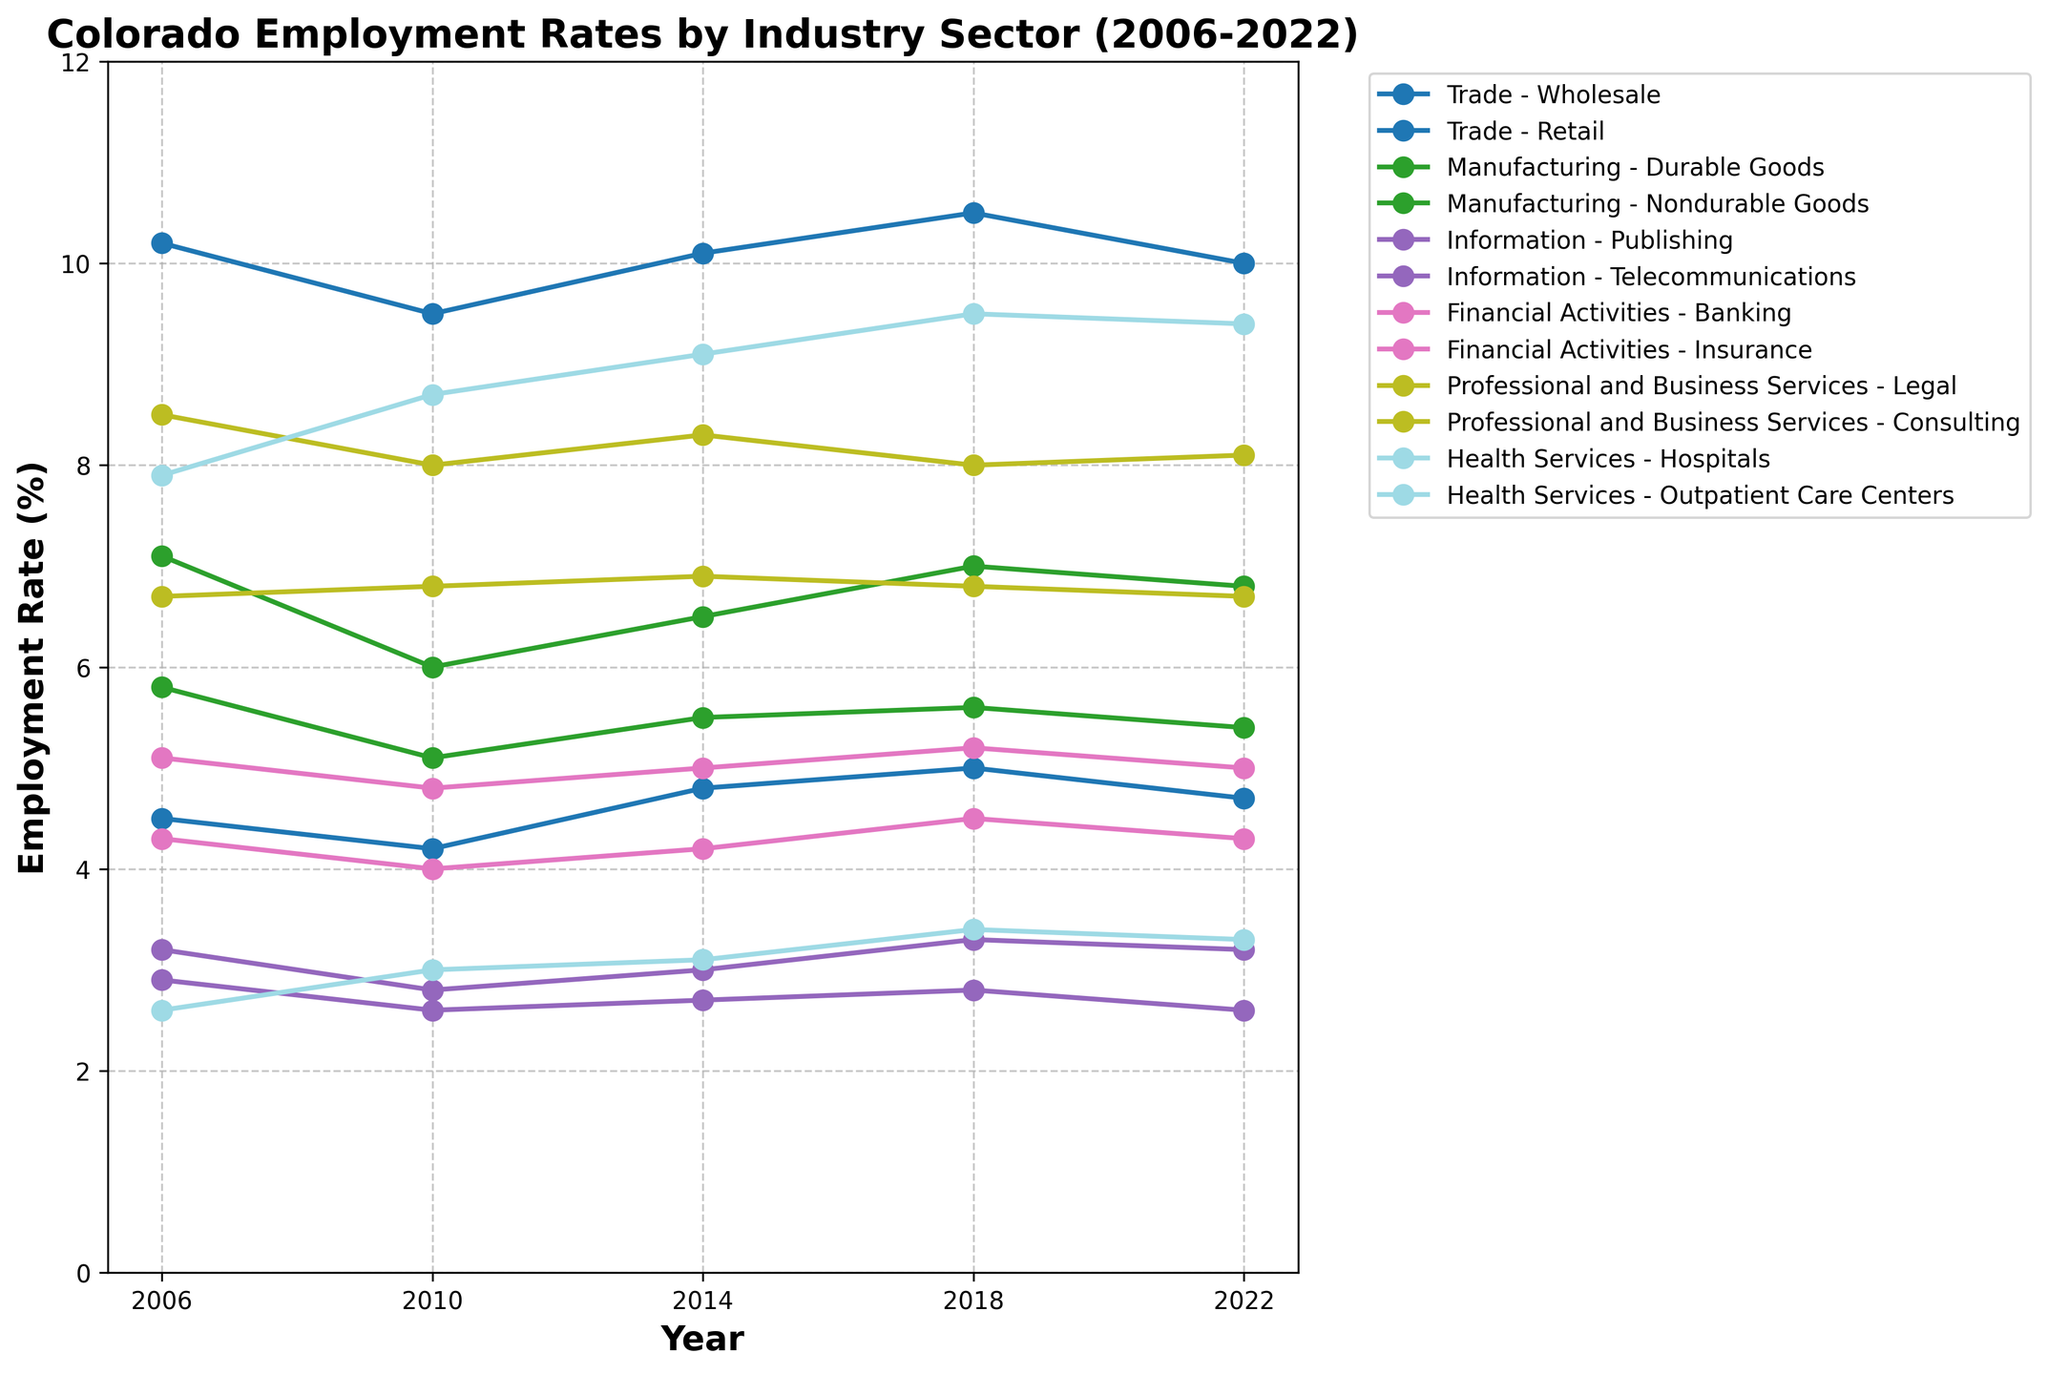What is the title of the figure? The title of the figure is usually placed at the top and provides a summary of what the plot represents. In this case, the title is meant to describe the data being presented.
Answer: Colorado Employment Rates by Industry Sector (2006-2022) Which industry sector has the highest employment rate in 2022? To find the sector with the highest employment rate in 2022, look at the data points corresponding to 2022 and identify which sector's value is the highest.
Answer: Retail What is the trend of employment rates for the Outpatient Care Centers sector from 2006 to 2022? Identify the data points for the Outpatient Care Centers sector over the years from 2006 to 2022 and observe the overall trend (whether the values increase, decrease, or remain stable over time).
Answer: Increasing trend How does the employment rate in the Durable Goods Manufacturing sector in 2010 compare to that in 2018? Locate the data points for Durable Goods Manufacturing in 2010 and 2018 and compare the values to determine if there is an increase, decrease, or no change.
Answer: Increased Which year did the Hospitals sector have the largest employment rate? Check the employment rates for the Hospitals sector across all the years and see in which year it reaches its maximum value.
Answer: 2018 What is the difference in employment rates between Banking and Insurance in 2014? Find the employment rates for Banking and Insurance sectors for the year 2014 and subtract the Insurance rate from the Banking rate to find the difference.
Answer: 0.8 Did the Telecommunications sector experience any change in employment rate from 2006 to 2022? Look at the employment rates for the Telecommunications sector in 2006 and 2022 and compare these two values to determine if there's any change.
Answer: Decreased What is the average employment rate for the Consulting sector from 2006 to 2022? To find the average employment rate, sum all the employment rates for Consulting from 2006 to 2022 and divide by the number of years (5). Calculating: (8.5 + 8.0 + 8.3 + 8.0 + 8.1) / 5 = 40.9 / 5.
Answer: 8.18 Which two sectors in the Information industry had similar employment rates in 2010? Check the employment rates for sectors within Information in 2010 and find the two sectors that have close or matching values.
Answer: Publishing and Telecommunications 